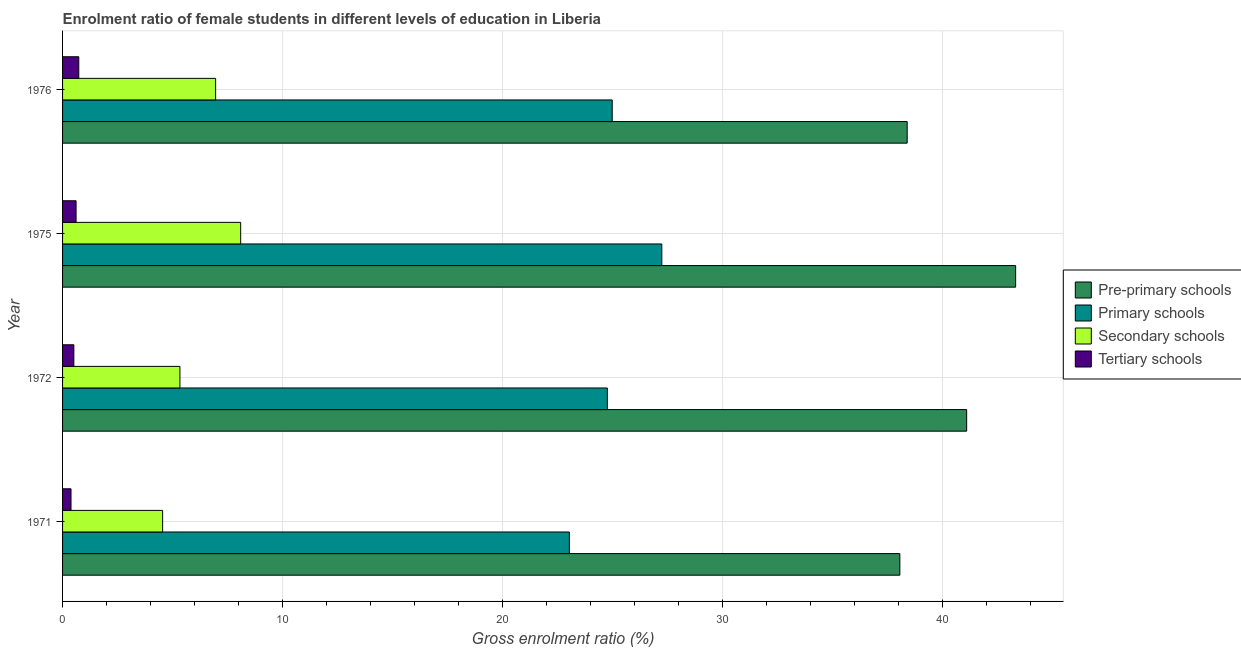How many bars are there on the 3rd tick from the top?
Keep it short and to the point. 4. What is the gross enrolment ratio(male) in pre-primary schools in 1975?
Ensure brevity in your answer.  43.34. Across all years, what is the maximum gross enrolment ratio(male) in primary schools?
Offer a very short reply. 27.25. Across all years, what is the minimum gross enrolment ratio(male) in tertiary schools?
Provide a succinct answer. 0.38. In which year was the gross enrolment ratio(male) in tertiary schools maximum?
Your answer should be very brief. 1976. In which year was the gross enrolment ratio(male) in pre-primary schools minimum?
Keep it short and to the point. 1971. What is the total gross enrolment ratio(male) in pre-primary schools in the graph?
Offer a very short reply. 160.93. What is the difference between the gross enrolment ratio(male) in primary schools in 1971 and that in 1972?
Offer a terse response. -1.73. What is the difference between the gross enrolment ratio(male) in primary schools in 1972 and the gross enrolment ratio(male) in secondary schools in 1975?
Your answer should be compact. 16.67. What is the average gross enrolment ratio(male) in secondary schools per year?
Your answer should be very brief. 6.24. In the year 1972, what is the difference between the gross enrolment ratio(male) in pre-primary schools and gross enrolment ratio(male) in tertiary schools?
Your answer should be compact. 40.6. What is the ratio of the gross enrolment ratio(male) in secondary schools in 1972 to that in 1976?
Your answer should be compact. 0.77. What is the difference between the highest and the second highest gross enrolment ratio(male) in tertiary schools?
Offer a very short reply. 0.12. What is the difference between the highest and the lowest gross enrolment ratio(male) in primary schools?
Keep it short and to the point. 4.2. In how many years, is the gross enrolment ratio(male) in primary schools greater than the average gross enrolment ratio(male) in primary schools taken over all years?
Make the answer very short. 1. What does the 1st bar from the top in 1972 represents?
Make the answer very short. Tertiary schools. What does the 4th bar from the bottom in 1976 represents?
Your answer should be very brief. Tertiary schools. How many years are there in the graph?
Make the answer very short. 4. What is the difference between two consecutive major ticks on the X-axis?
Ensure brevity in your answer.  10. Does the graph contain grids?
Ensure brevity in your answer.  Yes. How many legend labels are there?
Keep it short and to the point. 4. What is the title of the graph?
Your answer should be compact. Enrolment ratio of female students in different levels of education in Liberia. What is the label or title of the X-axis?
Make the answer very short. Gross enrolment ratio (%). What is the Gross enrolment ratio (%) in Pre-primary schools in 1971?
Provide a short and direct response. 38.07. What is the Gross enrolment ratio (%) of Primary schools in 1971?
Offer a terse response. 23.05. What is the Gross enrolment ratio (%) in Secondary schools in 1971?
Your answer should be compact. 4.55. What is the Gross enrolment ratio (%) of Tertiary schools in 1971?
Offer a very short reply. 0.38. What is the Gross enrolment ratio (%) of Pre-primary schools in 1972?
Offer a very short reply. 41.11. What is the Gross enrolment ratio (%) of Primary schools in 1972?
Ensure brevity in your answer.  24.77. What is the Gross enrolment ratio (%) in Secondary schools in 1972?
Offer a terse response. 5.34. What is the Gross enrolment ratio (%) of Tertiary schools in 1972?
Provide a short and direct response. 0.51. What is the Gross enrolment ratio (%) in Pre-primary schools in 1975?
Offer a very short reply. 43.34. What is the Gross enrolment ratio (%) in Primary schools in 1975?
Offer a terse response. 27.25. What is the Gross enrolment ratio (%) of Secondary schools in 1975?
Your answer should be very brief. 8.1. What is the Gross enrolment ratio (%) in Tertiary schools in 1975?
Your response must be concise. 0.61. What is the Gross enrolment ratio (%) of Pre-primary schools in 1976?
Offer a very short reply. 38.41. What is the Gross enrolment ratio (%) in Primary schools in 1976?
Keep it short and to the point. 24.99. What is the Gross enrolment ratio (%) in Secondary schools in 1976?
Provide a succinct answer. 6.96. What is the Gross enrolment ratio (%) of Tertiary schools in 1976?
Keep it short and to the point. 0.74. Across all years, what is the maximum Gross enrolment ratio (%) of Pre-primary schools?
Your answer should be compact. 43.34. Across all years, what is the maximum Gross enrolment ratio (%) in Primary schools?
Provide a succinct answer. 27.25. Across all years, what is the maximum Gross enrolment ratio (%) of Secondary schools?
Your answer should be very brief. 8.1. Across all years, what is the maximum Gross enrolment ratio (%) of Tertiary schools?
Provide a short and direct response. 0.74. Across all years, what is the minimum Gross enrolment ratio (%) in Pre-primary schools?
Give a very brief answer. 38.07. Across all years, what is the minimum Gross enrolment ratio (%) in Primary schools?
Ensure brevity in your answer.  23.05. Across all years, what is the minimum Gross enrolment ratio (%) of Secondary schools?
Ensure brevity in your answer.  4.55. Across all years, what is the minimum Gross enrolment ratio (%) of Tertiary schools?
Your answer should be very brief. 0.38. What is the total Gross enrolment ratio (%) of Pre-primary schools in the graph?
Ensure brevity in your answer.  160.93. What is the total Gross enrolment ratio (%) in Primary schools in the graph?
Offer a terse response. 100.06. What is the total Gross enrolment ratio (%) in Secondary schools in the graph?
Make the answer very short. 24.95. What is the total Gross enrolment ratio (%) in Tertiary schools in the graph?
Your answer should be very brief. 2.25. What is the difference between the Gross enrolment ratio (%) of Pre-primary schools in 1971 and that in 1972?
Provide a succinct answer. -3.04. What is the difference between the Gross enrolment ratio (%) of Primary schools in 1971 and that in 1972?
Ensure brevity in your answer.  -1.73. What is the difference between the Gross enrolment ratio (%) in Secondary schools in 1971 and that in 1972?
Offer a very short reply. -0.79. What is the difference between the Gross enrolment ratio (%) in Tertiary schools in 1971 and that in 1972?
Offer a very short reply. -0.13. What is the difference between the Gross enrolment ratio (%) of Pre-primary schools in 1971 and that in 1975?
Make the answer very short. -5.27. What is the difference between the Gross enrolment ratio (%) in Primary schools in 1971 and that in 1975?
Provide a succinct answer. -4.2. What is the difference between the Gross enrolment ratio (%) of Secondary schools in 1971 and that in 1975?
Your answer should be compact. -3.55. What is the difference between the Gross enrolment ratio (%) of Tertiary schools in 1971 and that in 1975?
Provide a succinct answer. -0.23. What is the difference between the Gross enrolment ratio (%) in Pre-primary schools in 1971 and that in 1976?
Provide a succinct answer. -0.33. What is the difference between the Gross enrolment ratio (%) in Primary schools in 1971 and that in 1976?
Make the answer very short. -1.95. What is the difference between the Gross enrolment ratio (%) of Secondary schools in 1971 and that in 1976?
Your answer should be very brief. -2.41. What is the difference between the Gross enrolment ratio (%) of Tertiary schools in 1971 and that in 1976?
Keep it short and to the point. -0.35. What is the difference between the Gross enrolment ratio (%) of Pre-primary schools in 1972 and that in 1975?
Provide a short and direct response. -2.23. What is the difference between the Gross enrolment ratio (%) in Primary schools in 1972 and that in 1975?
Give a very brief answer. -2.48. What is the difference between the Gross enrolment ratio (%) in Secondary schools in 1972 and that in 1975?
Offer a very short reply. -2.76. What is the difference between the Gross enrolment ratio (%) in Tertiary schools in 1972 and that in 1975?
Provide a succinct answer. -0.1. What is the difference between the Gross enrolment ratio (%) of Pre-primary schools in 1972 and that in 1976?
Keep it short and to the point. 2.7. What is the difference between the Gross enrolment ratio (%) in Primary schools in 1972 and that in 1976?
Provide a short and direct response. -0.22. What is the difference between the Gross enrolment ratio (%) of Secondary schools in 1972 and that in 1976?
Your answer should be compact. -1.62. What is the difference between the Gross enrolment ratio (%) of Tertiary schools in 1972 and that in 1976?
Provide a succinct answer. -0.22. What is the difference between the Gross enrolment ratio (%) in Pre-primary schools in 1975 and that in 1976?
Your response must be concise. 4.93. What is the difference between the Gross enrolment ratio (%) in Primary schools in 1975 and that in 1976?
Keep it short and to the point. 2.26. What is the difference between the Gross enrolment ratio (%) in Secondary schools in 1975 and that in 1976?
Provide a succinct answer. 1.14. What is the difference between the Gross enrolment ratio (%) of Tertiary schools in 1975 and that in 1976?
Give a very brief answer. -0.12. What is the difference between the Gross enrolment ratio (%) in Pre-primary schools in 1971 and the Gross enrolment ratio (%) in Primary schools in 1972?
Make the answer very short. 13.3. What is the difference between the Gross enrolment ratio (%) of Pre-primary schools in 1971 and the Gross enrolment ratio (%) of Secondary schools in 1972?
Your answer should be compact. 32.74. What is the difference between the Gross enrolment ratio (%) of Pre-primary schools in 1971 and the Gross enrolment ratio (%) of Tertiary schools in 1972?
Offer a very short reply. 37.56. What is the difference between the Gross enrolment ratio (%) of Primary schools in 1971 and the Gross enrolment ratio (%) of Secondary schools in 1972?
Offer a terse response. 17.71. What is the difference between the Gross enrolment ratio (%) in Primary schools in 1971 and the Gross enrolment ratio (%) in Tertiary schools in 1972?
Give a very brief answer. 22.53. What is the difference between the Gross enrolment ratio (%) in Secondary schools in 1971 and the Gross enrolment ratio (%) in Tertiary schools in 1972?
Make the answer very short. 4.04. What is the difference between the Gross enrolment ratio (%) of Pre-primary schools in 1971 and the Gross enrolment ratio (%) of Primary schools in 1975?
Provide a short and direct response. 10.82. What is the difference between the Gross enrolment ratio (%) in Pre-primary schools in 1971 and the Gross enrolment ratio (%) in Secondary schools in 1975?
Make the answer very short. 29.98. What is the difference between the Gross enrolment ratio (%) in Pre-primary schools in 1971 and the Gross enrolment ratio (%) in Tertiary schools in 1975?
Your response must be concise. 37.46. What is the difference between the Gross enrolment ratio (%) of Primary schools in 1971 and the Gross enrolment ratio (%) of Secondary schools in 1975?
Keep it short and to the point. 14.95. What is the difference between the Gross enrolment ratio (%) of Primary schools in 1971 and the Gross enrolment ratio (%) of Tertiary schools in 1975?
Your response must be concise. 22.43. What is the difference between the Gross enrolment ratio (%) in Secondary schools in 1971 and the Gross enrolment ratio (%) in Tertiary schools in 1975?
Provide a short and direct response. 3.94. What is the difference between the Gross enrolment ratio (%) of Pre-primary schools in 1971 and the Gross enrolment ratio (%) of Primary schools in 1976?
Keep it short and to the point. 13.08. What is the difference between the Gross enrolment ratio (%) of Pre-primary schools in 1971 and the Gross enrolment ratio (%) of Secondary schools in 1976?
Your response must be concise. 31.11. What is the difference between the Gross enrolment ratio (%) of Pre-primary schools in 1971 and the Gross enrolment ratio (%) of Tertiary schools in 1976?
Keep it short and to the point. 37.34. What is the difference between the Gross enrolment ratio (%) of Primary schools in 1971 and the Gross enrolment ratio (%) of Secondary schools in 1976?
Ensure brevity in your answer.  16.09. What is the difference between the Gross enrolment ratio (%) of Primary schools in 1971 and the Gross enrolment ratio (%) of Tertiary schools in 1976?
Provide a succinct answer. 22.31. What is the difference between the Gross enrolment ratio (%) in Secondary schools in 1971 and the Gross enrolment ratio (%) in Tertiary schools in 1976?
Offer a very short reply. 3.81. What is the difference between the Gross enrolment ratio (%) in Pre-primary schools in 1972 and the Gross enrolment ratio (%) in Primary schools in 1975?
Give a very brief answer. 13.86. What is the difference between the Gross enrolment ratio (%) of Pre-primary schools in 1972 and the Gross enrolment ratio (%) of Secondary schools in 1975?
Ensure brevity in your answer.  33.01. What is the difference between the Gross enrolment ratio (%) in Pre-primary schools in 1972 and the Gross enrolment ratio (%) in Tertiary schools in 1975?
Give a very brief answer. 40.5. What is the difference between the Gross enrolment ratio (%) of Primary schools in 1972 and the Gross enrolment ratio (%) of Secondary schools in 1975?
Offer a terse response. 16.67. What is the difference between the Gross enrolment ratio (%) in Primary schools in 1972 and the Gross enrolment ratio (%) in Tertiary schools in 1975?
Offer a terse response. 24.16. What is the difference between the Gross enrolment ratio (%) of Secondary schools in 1972 and the Gross enrolment ratio (%) of Tertiary schools in 1975?
Provide a succinct answer. 4.72. What is the difference between the Gross enrolment ratio (%) in Pre-primary schools in 1972 and the Gross enrolment ratio (%) in Primary schools in 1976?
Your response must be concise. 16.12. What is the difference between the Gross enrolment ratio (%) in Pre-primary schools in 1972 and the Gross enrolment ratio (%) in Secondary schools in 1976?
Provide a short and direct response. 34.15. What is the difference between the Gross enrolment ratio (%) in Pre-primary schools in 1972 and the Gross enrolment ratio (%) in Tertiary schools in 1976?
Offer a very short reply. 40.37. What is the difference between the Gross enrolment ratio (%) of Primary schools in 1972 and the Gross enrolment ratio (%) of Secondary schools in 1976?
Ensure brevity in your answer.  17.81. What is the difference between the Gross enrolment ratio (%) of Primary schools in 1972 and the Gross enrolment ratio (%) of Tertiary schools in 1976?
Your answer should be very brief. 24.04. What is the difference between the Gross enrolment ratio (%) of Secondary schools in 1972 and the Gross enrolment ratio (%) of Tertiary schools in 1976?
Your answer should be compact. 4.6. What is the difference between the Gross enrolment ratio (%) in Pre-primary schools in 1975 and the Gross enrolment ratio (%) in Primary schools in 1976?
Make the answer very short. 18.34. What is the difference between the Gross enrolment ratio (%) in Pre-primary schools in 1975 and the Gross enrolment ratio (%) in Secondary schools in 1976?
Your answer should be compact. 36.38. What is the difference between the Gross enrolment ratio (%) in Pre-primary schools in 1975 and the Gross enrolment ratio (%) in Tertiary schools in 1976?
Your response must be concise. 42.6. What is the difference between the Gross enrolment ratio (%) in Primary schools in 1975 and the Gross enrolment ratio (%) in Secondary schools in 1976?
Make the answer very short. 20.29. What is the difference between the Gross enrolment ratio (%) in Primary schools in 1975 and the Gross enrolment ratio (%) in Tertiary schools in 1976?
Offer a very short reply. 26.51. What is the difference between the Gross enrolment ratio (%) of Secondary schools in 1975 and the Gross enrolment ratio (%) of Tertiary schools in 1976?
Your response must be concise. 7.36. What is the average Gross enrolment ratio (%) of Pre-primary schools per year?
Offer a very short reply. 40.23. What is the average Gross enrolment ratio (%) in Primary schools per year?
Offer a terse response. 25.02. What is the average Gross enrolment ratio (%) of Secondary schools per year?
Provide a short and direct response. 6.24. What is the average Gross enrolment ratio (%) in Tertiary schools per year?
Keep it short and to the point. 0.56. In the year 1971, what is the difference between the Gross enrolment ratio (%) in Pre-primary schools and Gross enrolment ratio (%) in Primary schools?
Your answer should be very brief. 15.03. In the year 1971, what is the difference between the Gross enrolment ratio (%) of Pre-primary schools and Gross enrolment ratio (%) of Secondary schools?
Give a very brief answer. 33.52. In the year 1971, what is the difference between the Gross enrolment ratio (%) of Pre-primary schools and Gross enrolment ratio (%) of Tertiary schools?
Ensure brevity in your answer.  37.69. In the year 1971, what is the difference between the Gross enrolment ratio (%) in Primary schools and Gross enrolment ratio (%) in Secondary schools?
Give a very brief answer. 18.5. In the year 1971, what is the difference between the Gross enrolment ratio (%) of Primary schools and Gross enrolment ratio (%) of Tertiary schools?
Your answer should be compact. 22.66. In the year 1971, what is the difference between the Gross enrolment ratio (%) in Secondary schools and Gross enrolment ratio (%) in Tertiary schools?
Keep it short and to the point. 4.17. In the year 1972, what is the difference between the Gross enrolment ratio (%) in Pre-primary schools and Gross enrolment ratio (%) in Primary schools?
Offer a very short reply. 16.34. In the year 1972, what is the difference between the Gross enrolment ratio (%) of Pre-primary schools and Gross enrolment ratio (%) of Secondary schools?
Your response must be concise. 35.77. In the year 1972, what is the difference between the Gross enrolment ratio (%) of Pre-primary schools and Gross enrolment ratio (%) of Tertiary schools?
Make the answer very short. 40.6. In the year 1972, what is the difference between the Gross enrolment ratio (%) in Primary schools and Gross enrolment ratio (%) in Secondary schools?
Offer a very short reply. 19.44. In the year 1972, what is the difference between the Gross enrolment ratio (%) of Primary schools and Gross enrolment ratio (%) of Tertiary schools?
Offer a terse response. 24.26. In the year 1972, what is the difference between the Gross enrolment ratio (%) of Secondary schools and Gross enrolment ratio (%) of Tertiary schools?
Keep it short and to the point. 4.82. In the year 1975, what is the difference between the Gross enrolment ratio (%) of Pre-primary schools and Gross enrolment ratio (%) of Primary schools?
Your response must be concise. 16.09. In the year 1975, what is the difference between the Gross enrolment ratio (%) in Pre-primary schools and Gross enrolment ratio (%) in Secondary schools?
Provide a short and direct response. 35.24. In the year 1975, what is the difference between the Gross enrolment ratio (%) in Pre-primary schools and Gross enrolment ratio (%) in Tertiary schools?
Your answer should be very brief. 42.72. In the year 1975, what is the difference between the Gross enrolment ratio (%) in Primary schools and Gross enrolment ratio (%) in Secondary schools?
Provide a short and direct response. 19.15. In the year 1975, what is the difference between the Gross enrolment ratio (%) in Primary schools and Gross enrolment ratio (%) in Tertiary schools?
Make the answer very short. 26.64. In the year 1975, what is the difference between the Gross enrolment ratio (%) in Secondary schools and Gross enrolment ratio (%) in Tertiary schools?
Your response must be concise. 7.48. In the year 1976, what is the difference between the Gross enrolment ratio (%) in Pre-primary schools and Gross enrolment ratio (%) in Primary schools?
Ensure brevity in your answer.  13.41. In the year 1976, what is the difference between the Gross enrolment ratio (%) in Pre-primary schools and Gross enrolment ratio (%) in Secondary schools?
Keep it short and to the point. 31.45. In the year 1976, what is the difference between the Gross enrolment ratio (%) of Pre-primary schools and Gross enrolment ratio (%) of Tertiary schools?
Make the answer very short. 37.67. In the year 1976, what is the difference between the Gross enrolment ratio (%) of Primary schools and Gross enrolment ratio (%) of Secondary schools?
Your response must be concise. 18.03. In the year 1976, what is the difference between the Gross enrolment ratio (%) in Primary schools and Gross enrolment ratio (%) in Tertiary schools?
Ensure brevity in your answer.  24.26. In the year 1976, what is the difference between the Gross enrolment ratio (%) of Secondary schools and Gross enrolment ratio (%) of Tertiary schools?
Offer a very short reply. 6.22. What is the ratio of the Gross enrolment ratio (%) of Pre-primary schools in 1971 to that in 1972?
Give a very brief answer. 0.93. What is the ratio of the Gross enrolment ratio (%) of Primary schools in 1971 to that in 1972?
Your answer should be very brief. 0.93. What is the ratio of the Gross enrolment ratio (%) of Secondary schools in 1971 to that in 1972?
Offer a terse response. 0.85. What is the ratio of the Gross enrolment ratio (%) in Tertiary schools in 1971 to that in 1972?
Offer a very short reply. 0.75. What is the ratio of the Gross enrolment ratio (%) in Pre-primary schools in 1971 to that in 1975?
Your response must be concise. 0.88. What is the ratio of the Gross enrolment ratio (%) in Primary schools in 1971 to that in 1975?
Your answer should be compact. 0.85. What is the ratio of the Gross enrolment ratio (%) of Secondary schools in 1971 to that in 1975?
Provide a succinct answer. 0.56. What is the ratio of the Gross enrolment ratio (%) of Tertiary schools in 1971 to that in 1975?
Ensure brevity in your answer.  0.63. What is the ratio of the Gross enrolment ratio (%) in Pre-primary schools in 1971 to that in 1976?
Offer a very short reply. 0.99. What is the ratio of the Gross enrolment ratio (%) of Primary schools in 1971 to that in 1976?
Ensure brevity in your answer.  0.92. What is the ratio of the Gross enrolment ratio (%) in Secondary schools in 1971 to that in 1976?
Your answer should be very brief. 0.65. What is the ratio of the Gross enrolment ratio (%) of Tertiary schools in 1971 to that in 1976?
Your answer should be compact. 0.52. What is the ratio of the Gross enrolment ratio (%) in Pre-primary schools in 1972 to that in 1975?
Provide a short and direct response. 0.95. What is the ratio of the Gross enrolment ratio (%) in Primary schools in 1972 to that in 1975?
Provide a succinct answer. 0.91. What is the ratio of the Gross enrolment ratio (%) of Secondary schools in 1972 to that in 1975?
Keep it short and to the point. 0.66. What is the ratio of the Gross enrolment ratio (%) in Tertiary schools in 1972 to that in 1975?
Make the answer very short. 0.84. What is the ratio of the Gross enrolment ratio (%) in Pre-primary schools in 1972 to that in 1976?
Make the answer very short. 1.07. What is the ratio of the Gross enrolment ratio (%) in Secondary schools in 1972 to that in 1976?
Make the answer very short. 0.77. What is the ratio of the Gross enrolment ratio (%) of Tertiary schools in 1972 to that in 1976?
Give a very brief answer. 0.7. What is the ratio of the Gross enrolment ratio (%) in Pre-primary schools in 1975 to that in 1976?
Ensure brevity in your answer.  1.13. What is the ratio of the Gross enrolment ratio (%) in Primary schools in 1975 to that in 1976?
Ensure brevity in your answer.  1.09. What is the ratio of the Gross enrolment ratio (%) in Secondary schools in 1975 to that in 1976?
Ensure brevity in your answer.  1.16. What is the ratio of the Gross enrolment ratio (%) of Tertiary schools in 1975 to that in 1976?
Keep it short and to the point. 0.83. What is the difference between the highest and the second highest Gross enrolment ratio (%) in Pre-primary schools?
Provide a succinct answer. 2.23. What is the difference between the highest and the second highest Gross enrolment ratio (%) of Primary schools?
Provide a short and direct response. 2.26. What is the difference between the highest and the second highest Gross enrolment ratio (%) in Secondary schools?
Give a very brief answer. 1.14. What is the difference between the highest and the second highest Gross enrolment ratio (%) of Tertiary schools?
Keep it short and to the point. 0.12. What is the difference between the highest and the lowest Gross enrolment ratio (%) of Pre-primary schools?
Provide a short and direct response. 5.27. What is the difference between the highest and the lowest Gross enrolment ratio (%) in Primary schools?
Provide a short and direct response. 4.2. What is the difference between the highest and the lowest Gross enrolment ratio (%) in Secondary schools?
Your answer should be compact. 3.55. What is the difference between the highest and the lowest Gross enrolment ratio (%) in Tertiary schools?
Offer a terse response. 0.35. 